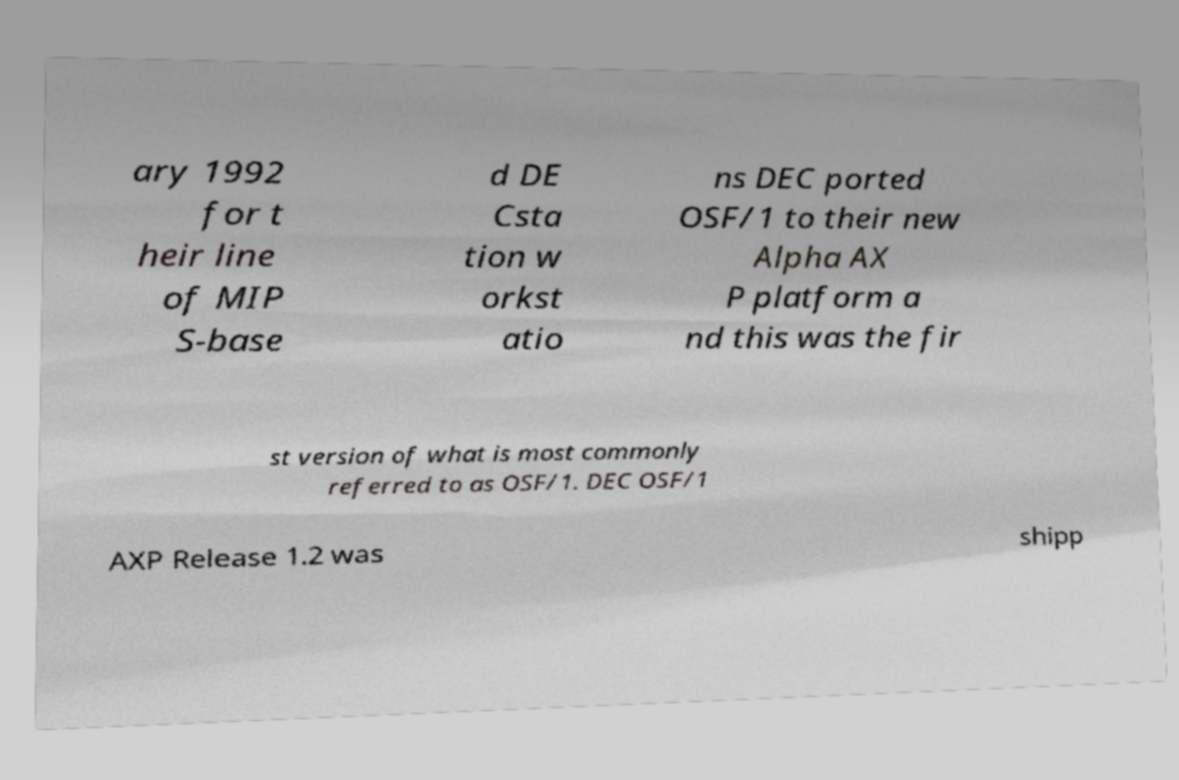For documentation purposes, I need the text within this image transcribed. Could you provide that? ary 1992 for t heir line of MIP S-base d DE Csta tion w orkst atio ns DEC ported OSF/1 to their new Alpha AX P platform a nd this was the fir st version of what is most commonly referred to as OSF/1. DEC OSF/1 AXP Release 1.2 was shipp 